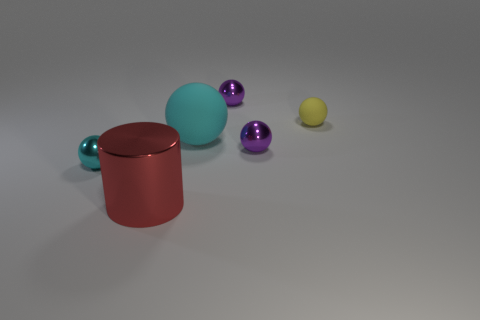Subtract all cyan spheres. How many spheres are left? 3 Subtract all red cylinders. How many cyan balls are left? 2 Subtract all yellow balls. How many balls are left? 4 Add 1 large gray matte cylinders. How many objects exist? 7 Subtract all balls. How many objects are left? 1 Subtract all brown balls. Subtract all yellow cylinders. How many balls are left? 5 Subtract 1 yellow balls. How many objects are left? 5 Subtract all small metal spheres. Subtract all purple metal balls. How many objects are left? 1 Add 4 purple balls. How many purple balls are left? 6 Add 5 tiny matte things. How many tiny matte things exist? 6 